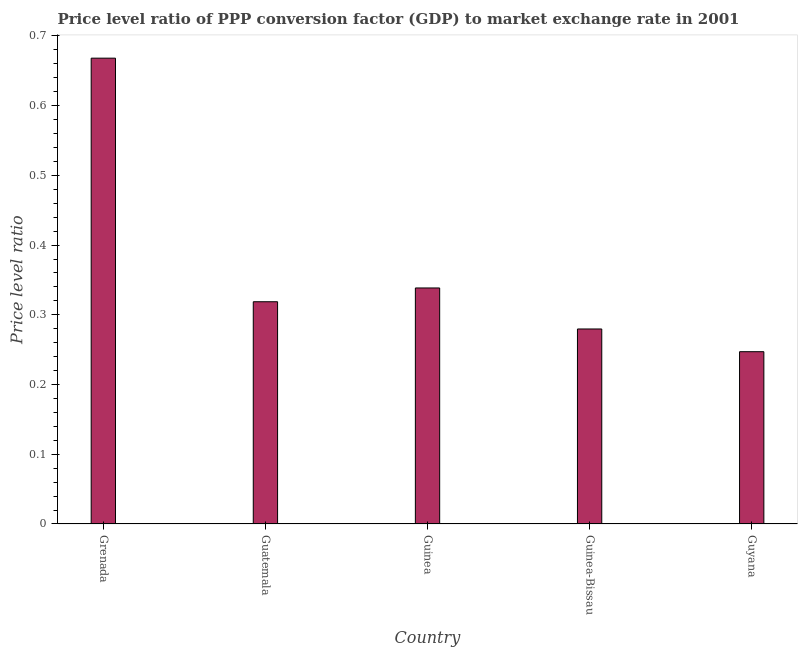Does the graph contain grids?
Make the answer very short. No. What is the title of the graph?
Provide a short and direct response. Price level ratio of PPP conversion factor (GDP) to market exchange rate in 2001. What is the label or title of the Y-axis?
Your response must be concise. Price level ratio. What is the price level ratio in Guatemala?
Give a very brief answer. 0.32. Across all countries, what is the maximum price level ratio?
Provide a succinct answer. 0.67. Across all countries, what is the minimum price level ratio?
Make the answer very short. 0.25. In which country was the price level ratio maximum?
Your response must be concise. Grenada. In which country was the price level ratio minimum?
Offer a terse response. Guyana. What is the sum of the price level ratio?
Your response must be concise. 1.85. What is the difference between the price level ratio in Guinea and Guyana?
Keep it short and to the point. 0.09. What is the average price level ratio per country?
Keep it short and to the point. 0.37. What is the median price level ratio?
Offer a terse response. 0.32. What is the ratio of the price level ratio in Grenada to that in Guinea-Bissau?
Offer a terse response. 2.39. What is the difference between the highest and the second highest price level ratio?
Your answer should be very brief. 0.33. Is the sum of the price level ratio in Guatemala and Guinea greater than the maximum price level ratio across all countries?
Your answer should be very brief. No. What is the difference between the highest and the lowest price level ratio?
Offer a very short reply. 0.42. In how many countries, is the price level ratio greater than the average price level ratio taken over all countries?
Ensure brevity in your answer.  1. How many bars are there?
Your answer should be compact. 5. What is the difference between two consecutive major ticks on the Y-axis?
Make the answer very short. 0.1. Are the values on the major ticks of Y-axis written in scientific E-notation?
Keep it short and to the point. No. What is the Price level ratio in Grenada?
Your answer should be very brief. 0.67. What is the Price level ratio of Guatemala?
Give a very brief answer. 0.32. What is the Price level ratio of Guinea?
Give a very brief answer. 0.34. What is the Price level ratio in Guinea-Bissau?
Ensure brevity in your answer.  0.28. What is the Price level ratio of Guyana?
Offer a terse response. 0.25. What is the difference between the Price level ratio in Grenada and Guatemala?
Offer a very short reply. 0.35. What is the difference between the Price level ratio in Grenada and Guinea?
Offer a very short reply. 0.33. What is the difference between the Price level ratio in Grenada and Guinea-Bissau?
Offer a terse response. 0.39. What is the difference between the Price level ratio in Grenada and Guyana?
Your answer should be very brief. 0.42. What is the difference between the Price level ratio in Guatemala and Guinea?
Give a very brief answer. -0.02. What is the difference between the Price level ratio in Guatemala and Guinea-Bissau?
Your response must be concise. 0.04. What is the difference between the Price level ratio in Guatemala and Guyana?
Your response must be concise. 0.07. What is the difference between the Price level ratio in Guinea and Guinea-Bissau?
Your answer should be compact. 0.06. What is the difference between the Price level ratio in Guinea and Guyana?
Your response must be concise. 0.09. What is the difference between the Price level ratio in Guinea-Bissau and Guyana?
Your answer should be compact. 0.03. What is the ratio of the Price level ratio in Grenada to that in Guatemala?
Your response must be concise. 2.1. What is the ratio of the Price level ratio in Grenada to that in Guinea?
Your answer should be compact. 1.97. What is the ratio of the Price level ratio in Grenada to that in Guinea-Bissau?
Your response must be concise. 2.39. What is the ratio of the Price level ratio in Grenada to that in Guyana?
Your answer should be compact. 2.7. What is the ratio of the Price level ratio in Guatemala to that in Guinea?
Your response must be concise. 0.94. What is the ratio of the Price level ratio in Guatemala to that in Guinea-Bissau?
Keep it short and to the point. 1.14. What is the ratio of the Price level ratio in Guatemala to that in Guyana?
Give a very brief answer. 1.29. What is the ratio of the Price level ratio in Guinea to that in Guinea-Bissau?
Ensure brevity in your answer.  1.21. What is the ratio of the Price level ratio in Guinea to that in Guyana?
Give a very brief answer. 1.37. What is the ratio of the Price level ratio in Guinea-Bissau to that in Guyana?
Keep it short and to the point. 1.13. 